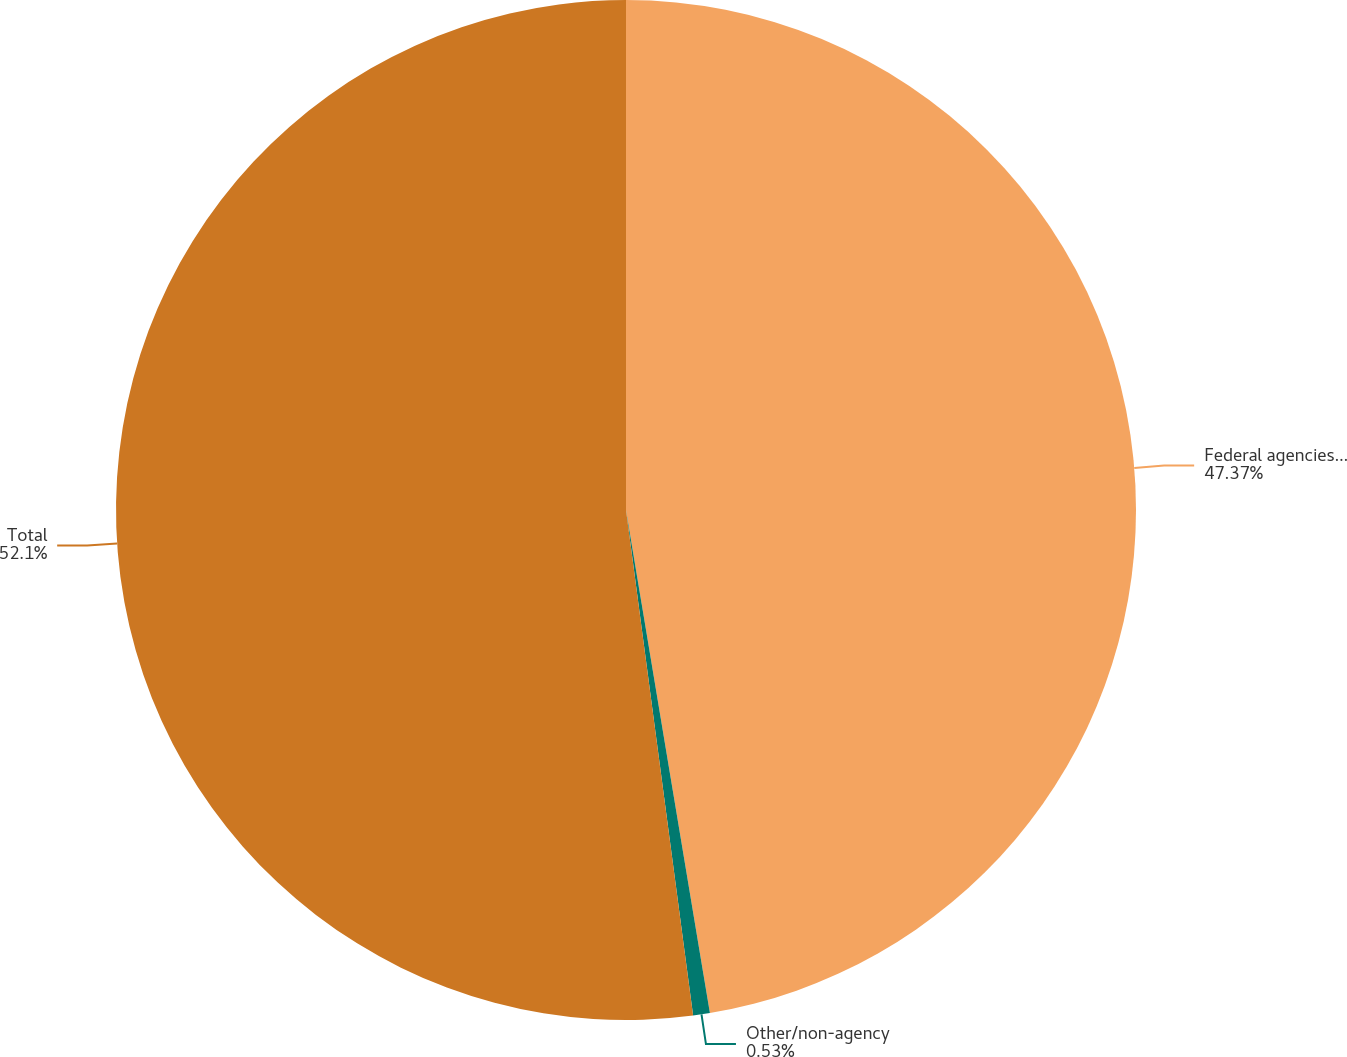Convert chart. <chart><loc_0><loc_0><loc_500><loc_500><pie_chart><fcel>Federal agencies and US<fcel>Other/non-agency<fcel>Total<nl><fcel>47.37%<fcel>0.53%<fcel>52.1%<nl></chart> 